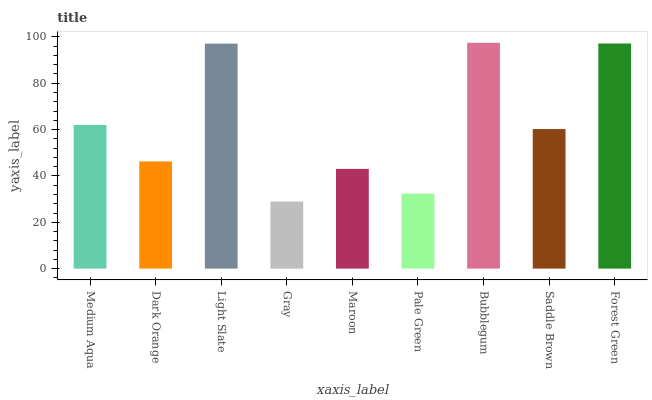Is Gray the minimum?
Answer yes or no. Yes. Is Bubblegum the maximum?
Answer yes or no. Yes. Is Dark Orange the minimum?
Answer yes or no. No. Is Dark Orange the maximum?
Answer yes or no. No. Is Medium Aqua greater than Dark Orange?
Answer yes or no. Yes. Is Dark Orange less than Medium Aqua?
Answer yes or no. Yes. Is Dark Orange greater than Medium Aqua?
Answer yes or no. No. Is Medium Aqua less than Dark Orange?
Answer yes or no. No. Is Saddle Brown the high median?
Answer yes or no. Yes. Is Saddle Brown the low median?
Answer yes or no. Yes. Is Forest Green the high median?
Answer yes or no. No. Is Medium Aqua the low median?
Answer yes or no. No. 